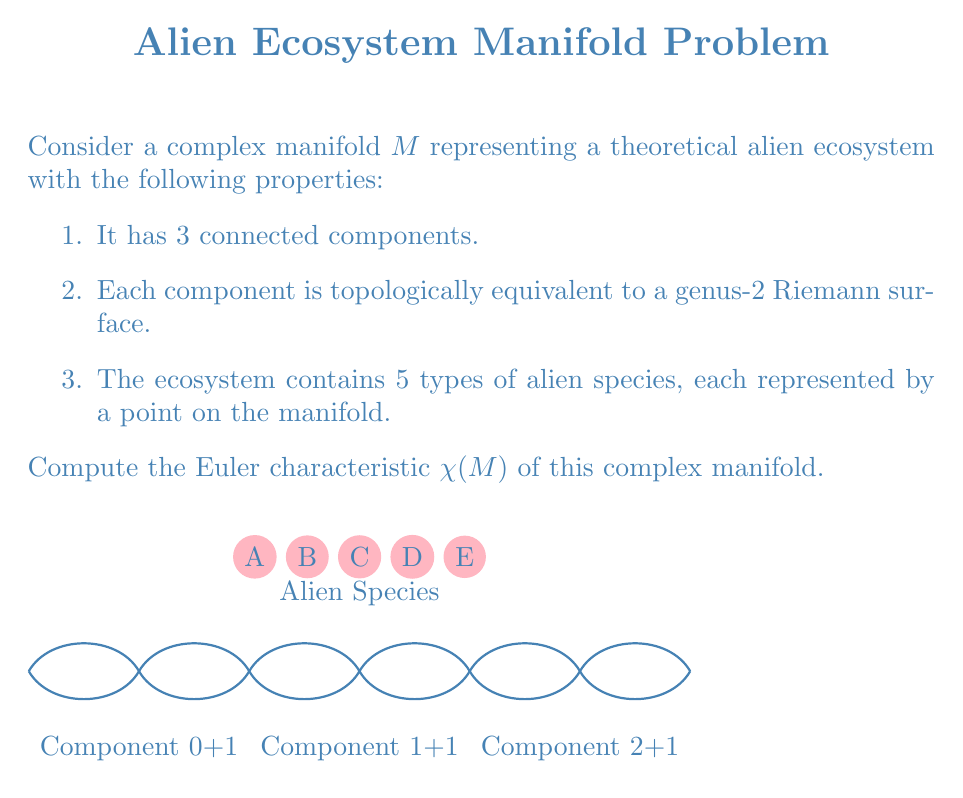Solve this math problem. Let's approach this step-by-step:

1) First, recall the formula for the Euler characteristic of a manifold:
   $$\chi(M) = \sum_{k=0}^{\dim M} (-1)^k b_k$$
   where $b_k$ are the Betti numbers.

2) For a genus-2 Riemann surface, the Betti numbers are:
   $b_0 = 1$ (one connected component)
   $b_1 = 4$ (four 1-dimensional holes)
   $b_2 = 1$ (one 2-dimensional hole)

3) Therefore, the Euler characteristic of a single genus-2 Riemann surface is:
   $$\chi = 1 - 4 + 1 = -2$$

4) Our manifold $M$ consists of 3 such components. The Euler characteristic is additive for disjoint unions, so:
   $$\chi(M) = 3 \cdot (-2) = -6$$

5) Now, we need to account for the 5 points representing alien species. Each point adds 1 to the Euler characteristic.

6) Thus, the final Euler characteristic is:
   $$\chi(M) = -6 + 5 = -1$$
Answer: $\chi(M) = -1$ 